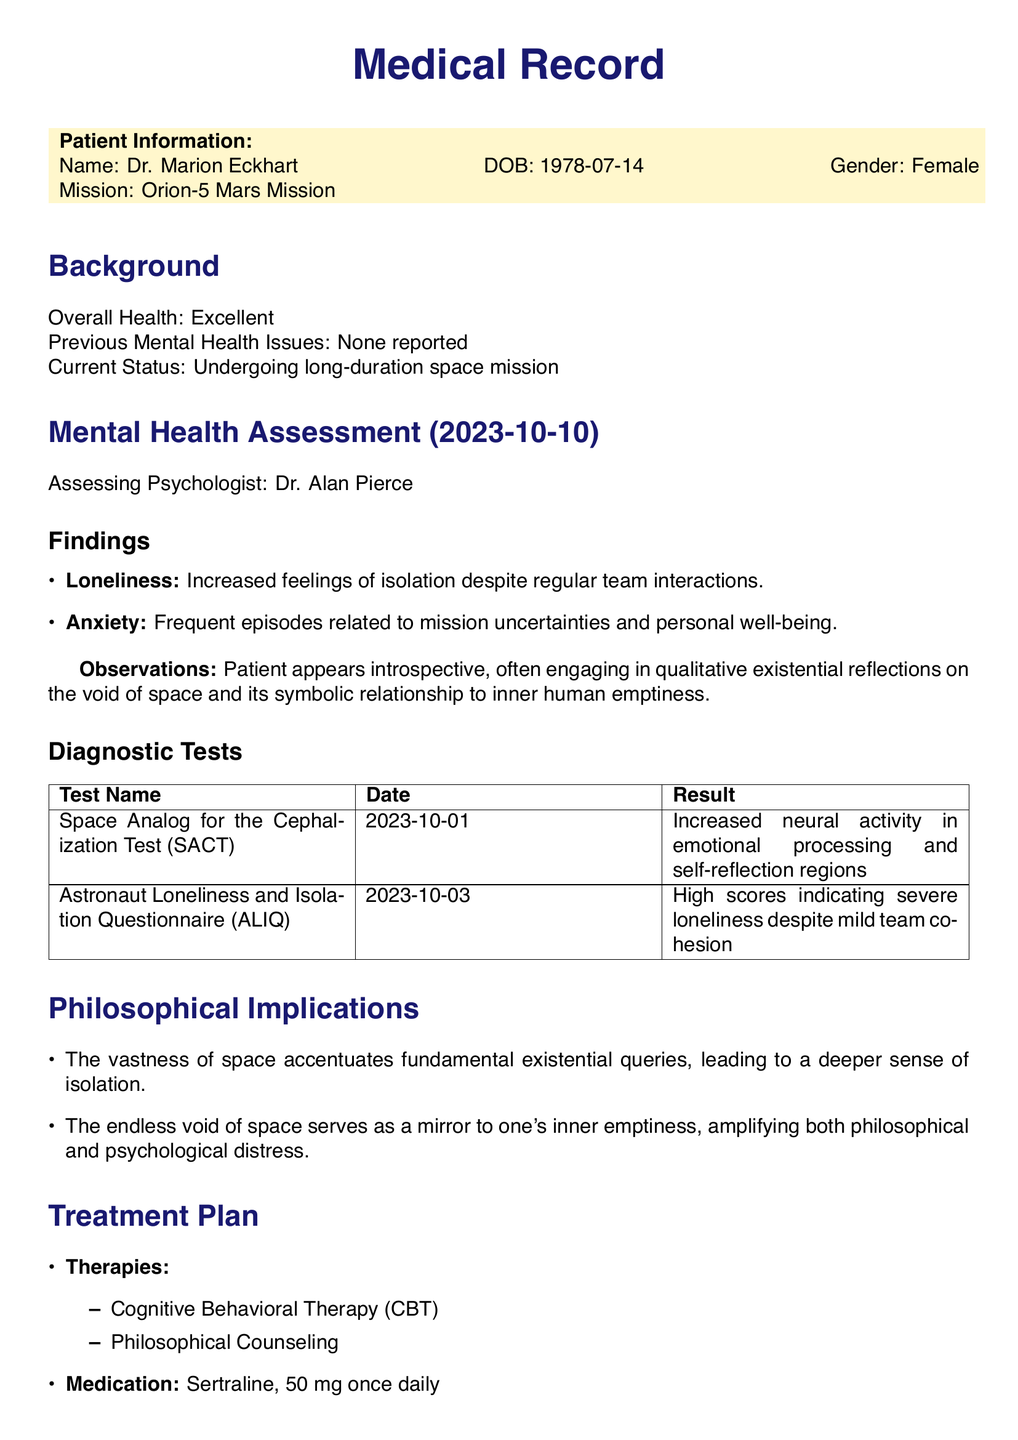What is the name of the patient? The patient's name is listed in the document as Dr. Marion Eckhart.
Answer: Dr. Marion Eckhart What is the date of the mental health assessment? The assessment date is explicitly stated in the document.
Answer: 2023-10-10 What medication is prescribed to Dr. Marion Eckhart? The document mentions the specific medication prescribed.
Answer: Sertraline, 50 mg once daily What was the result of the Astronaut Loneliness and Isolation Questionnaire? The document provides the result of the questionnaire.
Answer: High scores indicating severe loneliness Which therapies are included in the treatment plan? The treatment plan details the types of therapies suggested.
Answer: Cognitive Behavioral Therapy (CBT), Philosophical Counseling What are the findings regarding loneliness in the assessment? The findings section addresses the patient's feelings of loneliness.
Answer: Increased feelings of isolation despite regular team interactions What was the result of the SACT test? The document contains the result of the SACT test conducted on the patient.
Answer: Increased neural activity in emotional processing and self-reflection regions What is the next review date listed in the document? The document specifies the date for the next review.
Answer: 2023-10-24 What does the philosophical implications section state about the void of space? This section discusses the existential queries associated with space.
Answer: The endless void of space serves as a mirror to one's inner emptiness 